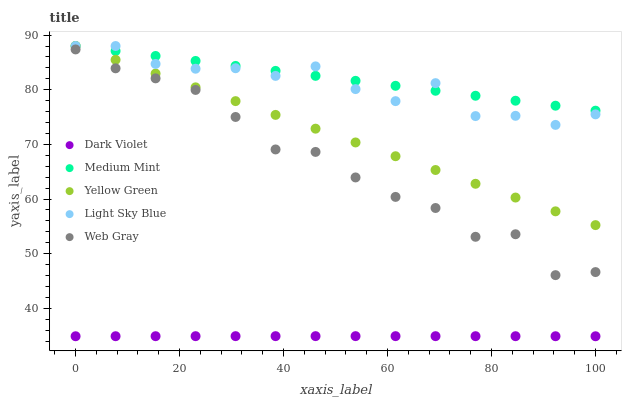Does Dark Violet have the minimum area under the curve?
Answer yes or no. Yes. Does Medium Mint have the maximum area under the curve?
Answer yes or no. Yes. Does Light Sky Blue have the minimum area under the curve?
Answer yes or no. No. Does Light Sky Blue have the maximum area under the curve?
Answer yes or no. No. Is Yellow Green the smoothest?
Answer yes or no. Yes. Is Light Sky Blue the roughest?
Answer yes or no. Yes. Is Web Gray the smoothest?
Answer yes or no. No. Is Web Gray the roughest?
Answer yes or no. No. Does Dark Violet have the lowest value?
Answer yes or no. Yes. Does Light Sky Blue have the lowest value?
Answer yes or no. No. Does Yellow Green have the highest value?
Answer yes or no. Yes. Does Web Gray have the highest value?
Answer yes or no. No. Is Dark Violet less than Light Sky Blue?
Answer yes or no. Yes. Is Yellow Green greater than Web Gray?
Answer yes or no. Yes. Does Medium Mint intersect Yellow Green?
Answer yes or no. Yes. Is Medium Mint less than Yellow Green?
Answer yes or no. No. Is Medium Mint greater than Yellow Green?
Answer yes or no. No. Does Dark Violet intersect Light Sky Blue?
Answer yes or no. No. 